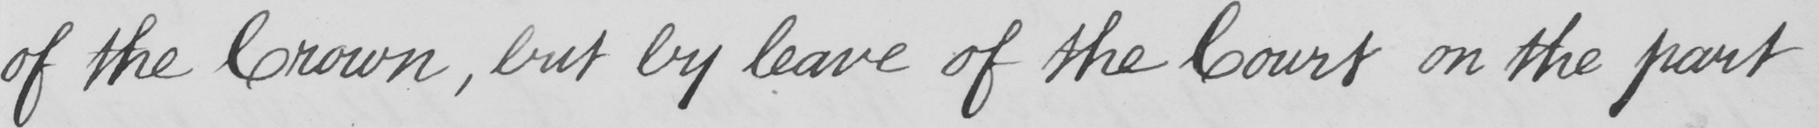Transcribe the text shown in this historical manuscript line. of the Crown , but by leave of the Court on the part 